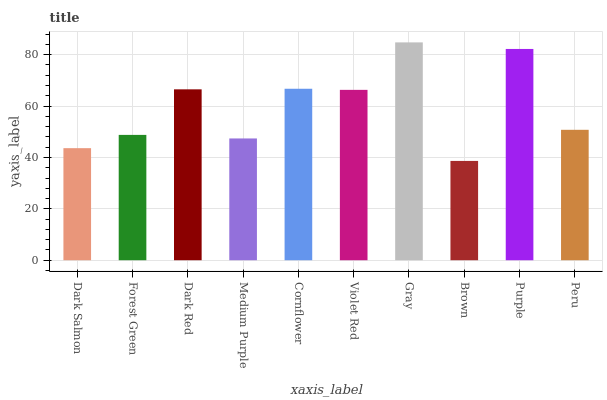Is Brown the minimum?
Answer yes or no. Yes. Is Gray the maximum?
Answer yes or no. Yes. Is Forest Green the minimum?
Answer yes or no. No. Is Forest Green the maximum?
Answer yes or no. No. Is Forest Green greater than Dark Salmon?
Answer yes or no. Yes. Is Dark Salmon less than Forest Green?
Answer yes or no. Yes. Is Dark Salmon greater than Forest Green?
Answer yes or no. No. Is Forest Green less than Dark Salmon?
Answer yes or no. No. Is Violet Red the high median?
Answer yes or no. Yes. Is Peru the low median?
Answer yes or no. Yes. Is Dark Salmon the high median?
Answer yes or no. No. Is Brown the low median?
Answer yes or no. No. 